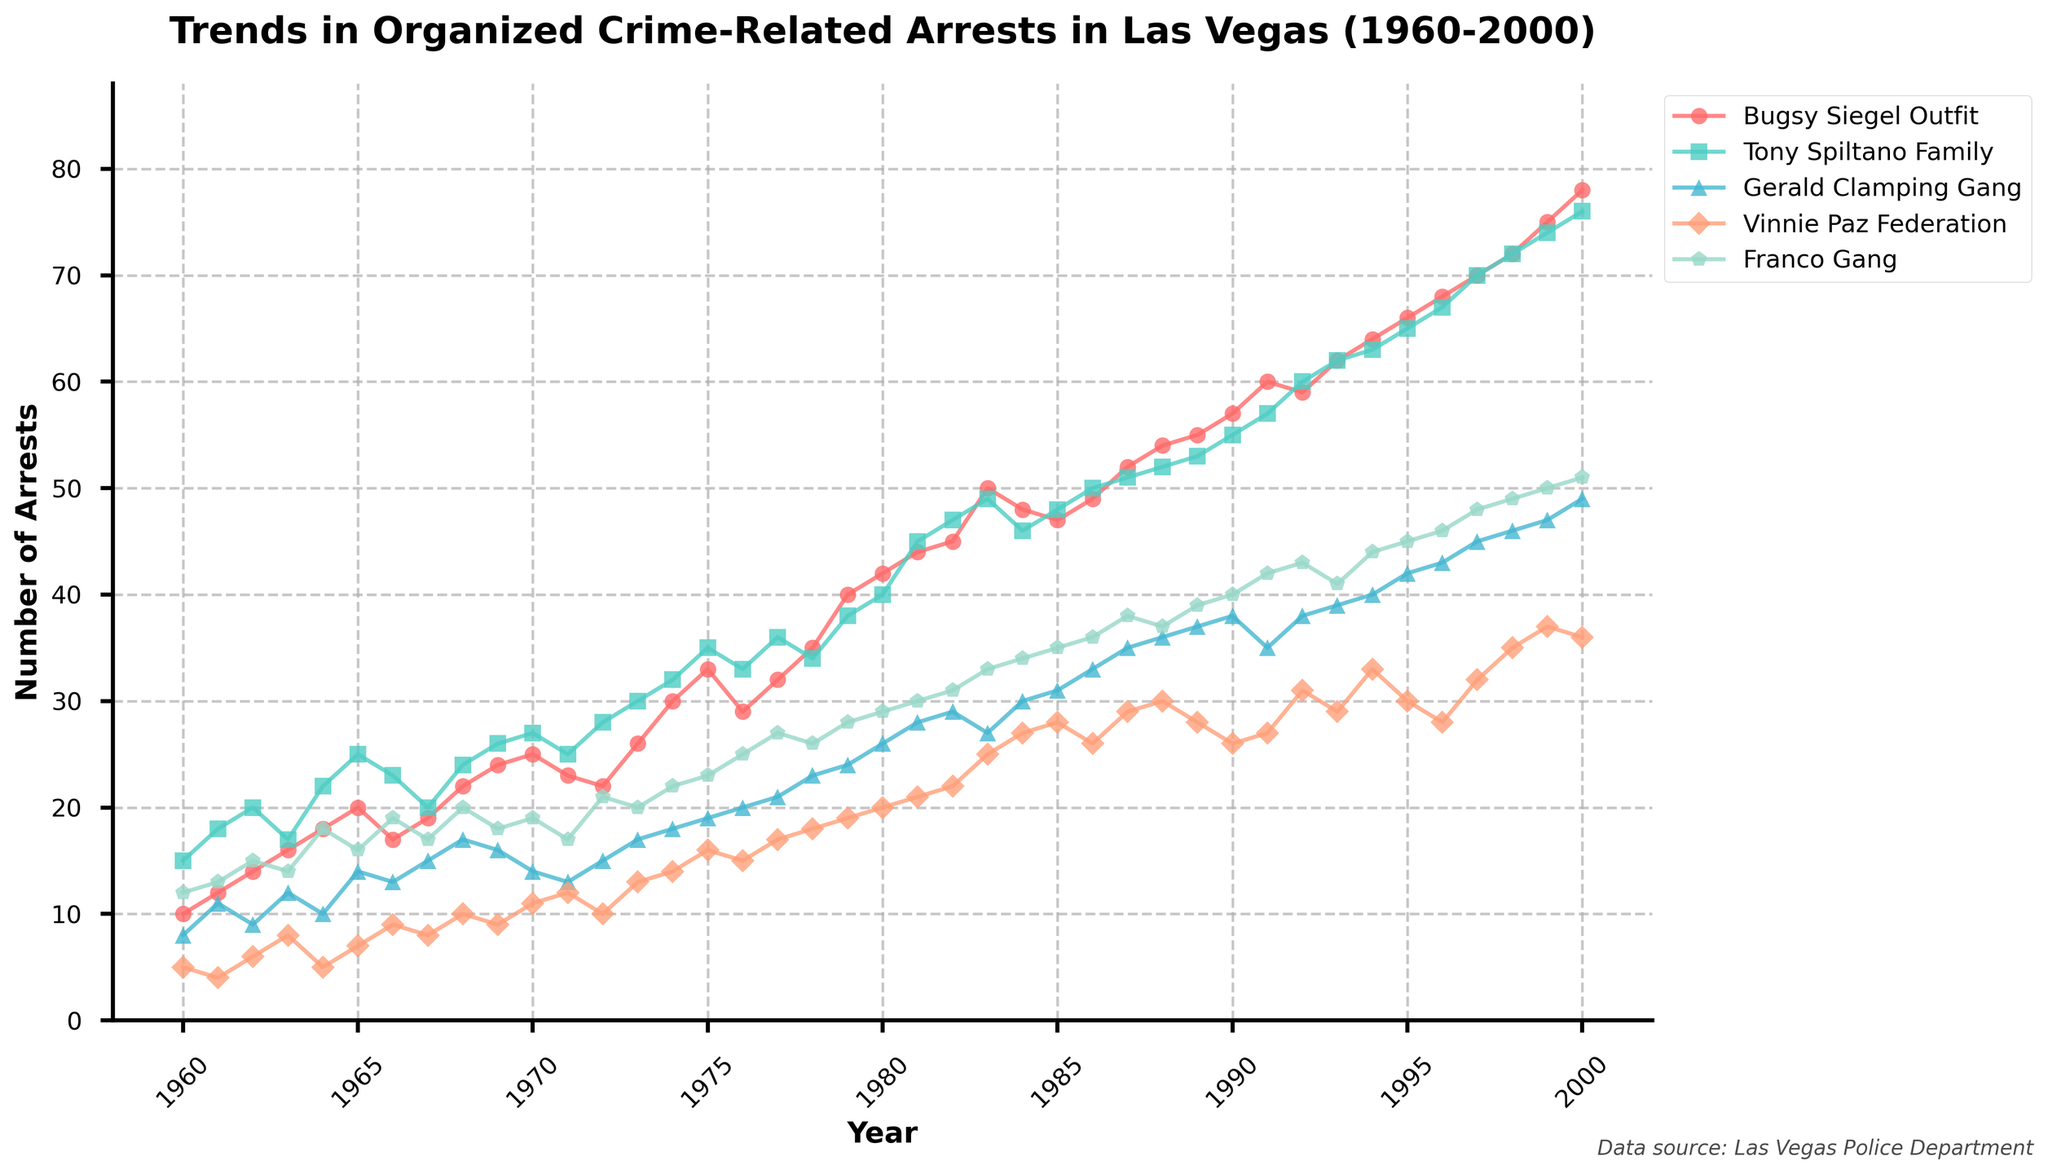Which year shows the highest number of arrests for the Franco Gang? Look at the line representing the Franco Gang and identify the peak point. The arrest numbers are highest in the year 2000.
Answer: 2000 What is the overall trend for arrests related to the Bugsy Siegel Outfit between 1960 and 2000? Observe the Bugsy Siegel Outfit line from start to end. The general trend shows a steady increase in the number of arrests over the years.
Answer: Increasing trend How do the number of arrests for the Vinnie Paz Federation in 1980 compare to those in 1970? Check the number of arrests for the Vinnie Paz Federation at both points. In 1980 there are 20 arrests, whereas in 1970 there are 11. Thus, 1980 has more arrests.
Answer: 1980 has more arrests During which decade did the Tony Spiltano Family see the most significant increase in arrests? Observe the line for the Tony Spiltano Family by decades: 1960s, 1970s, 1980s, and 1990s. The most significant increase is during the 1960s when arrests increased from 15 to 26.
Answer: 1960s Which crime group had the lowest number of arrests in 1991? Refer to the points for all crime groups in 1991. The Vinnie Paz Federation has 27 arrests, which is the lowest number among all groups.
Answer: Vinnie Paz Federation What is the difference in the number of arrests between the Gerald Clamping Gang and the Franco Gang in 1983? Check the arrest numbers for both groups in 1983: 27 for the Gerald Clamping Gang and 33 for the Franco Gang, then calculate the difference: 33 - 27 = 6.
Answer: 6 Which group showed a decreasing trend in arrests from 1989 to 1990? Look at the lines for all groups between 1989 and 1990. The Vinnie Paz Federation shows a decreasing trend from 28 arrests in 1989 to 26 in 1990.
Answer: Vinnie Paz Federation What is the median number of arrests for the Franco Gang in the 1970s? List the number of arrests for the Franco Gang from 1970 to 1979: 19, 17, 21, 20, 22, 23, 25, 27, 26, 28. The median value is the middle point, which is 22.
Answer: 22 Approximately how many arrests were made for the Bugsy Siegel Outfit in the 1990s? Sum the number of arrests for the Bugsy Siegel Outfit from 1990 to 1999: 57 + 60 + 59 + 62 + 64 + 66 + 68 + 70 + 72 + 75 = 653.
Answer: 653 